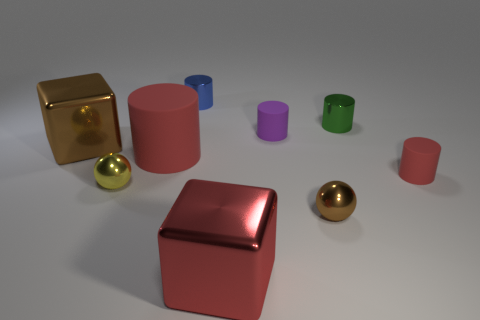Subtract all large cylinders. How many cylinders are left? 4 Subtract all purple cylinders. How many cylinders are left? 4 Subtract all cyan cylinders. Subtract all brown cubes. How many cylinders are left? 5 Add 1 big brown things. How many objects exist? 10 Subtract all cylinders. How many objects are left? 4 Add 3 cylinders. How many cylinders are left? 8 Add 8 small purple things. How many small purple things exist? 9 Subtract 0 gray blocks. How many objects are left? 9 Subtract all green things. Subtract all red shiny things. How many objects are left? 7 